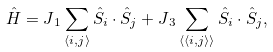<formula> <loc_0><loc_0><loc_500><loc_500>\hat { H } = J { _ { 1 } } \sum _ { \langle i , j \rangle } \hat { S } _ { i } \cdot \hat { S } _ { j } + J { _ { 3 } } \sum _ { \langle \langle i , j \rangle \rangle } \hat { S } _ { i } \cdot \hat { S } _ { j } ,</formula> 